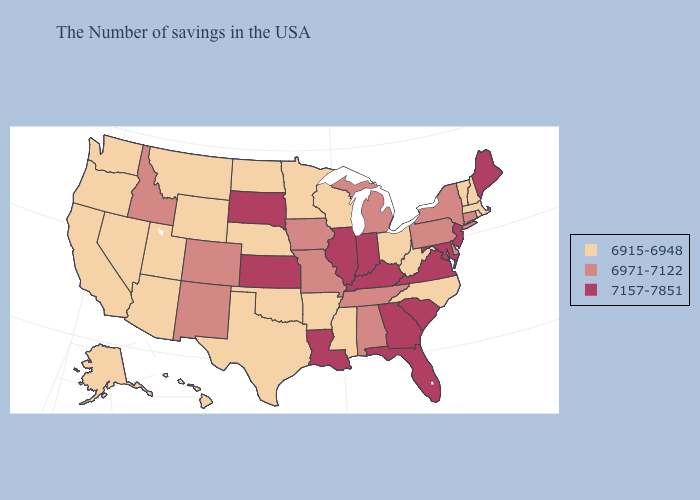Does the map have missing data?
Short answer required. No. What is the value of West Virginia?
Give a very brief answer. 6915-6948. What is the lowest value in the Northeast?
Write a very short answer. 6915-6948. Does Rhode Island have the highest value in the Northeast?
Short answer required. No. What is the lowest value in states that border Oklahoma?
Short answer required. 6915-6948. Which states have the lowest value in the USA?
Concise answer only. Massachusetts, Rhode Island, New Hampshire, Vermont, North Carolina, West Virginia, Ohio, Wisconsin, Mississippi, Arkansas, Minnesota, Nebraska, Oklahoma, Texas, North Dakota, Wyoming, Utah, Montana, Arizona, Nevada, California, Washington, Oregon, Alaska, Hawaii. What is the value of New Hampshire?
Give a very brief answer. 6915-6948. What is the highest value in states that border Minnesota?
Quick response, please. 7157-7851. How many symbols are there in the legend?
Be succinct. 3. Name the states that have a value in the range 7157-7851?
Keep it brief. Maine, New Jersey, Maryland, Virginia, South Carolina, Florida, Georgia, Kentucky, Indiana, Illinois, Louisiana, Kansas, South Dakota. What is the lowest value in the USA?
Keep it brief. 6915-6948. Name the states that have a value in the range 6915-6948?
Quick response, please. Massachusetts, Rhode Island, New Hampshire, Vermont, North Carolina, West Virginia, Ohio, Wisconsin, Mississippi, Arkansas, Minnesota, Nebraska, Oklahoma, Texas, North Dakota, Wyoming, Utah, Montana, Arizona, Nevada, California, Washington, Oregon, Alaska, Hawaii. What is the lowest value in states that border Oklahoma?
Answer briefly. 6915-6948. What is the value of Indiana?
Short answer required. 7157-7851. Does the map have missing data?
Write a very short answer. No. 